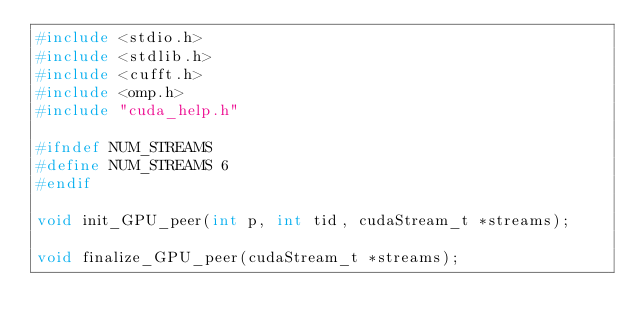Convert code to text. <code><loc_0><loc_0><loc_500><loc_500><_C_>#include <stdio.h>
#include <stdlib.h>
#include <cufft.h>
#include <omp.h>
#include "cuda_help.h"

#ifndef NUM_STREAMS
#define NUM_STREAMS 6
#endif

void init_GPU_peer(int p, int tid, cudaStream_t *streams);

void finalize_GPU_peer(cudaStream_t *streams);
</code> 